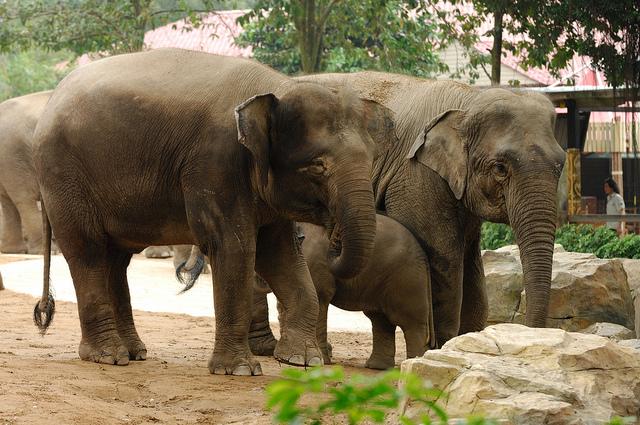What are the elephants doing?
Answer briefly. Standing. Are the animals likely in captivity?
Quick response, please. Yes. Are these elephants the same age?
Write a very short answer. No. How many elephants are there?
Concise answer only. 4. How many elephants are standing near the food?
Keep it brief. 3. 